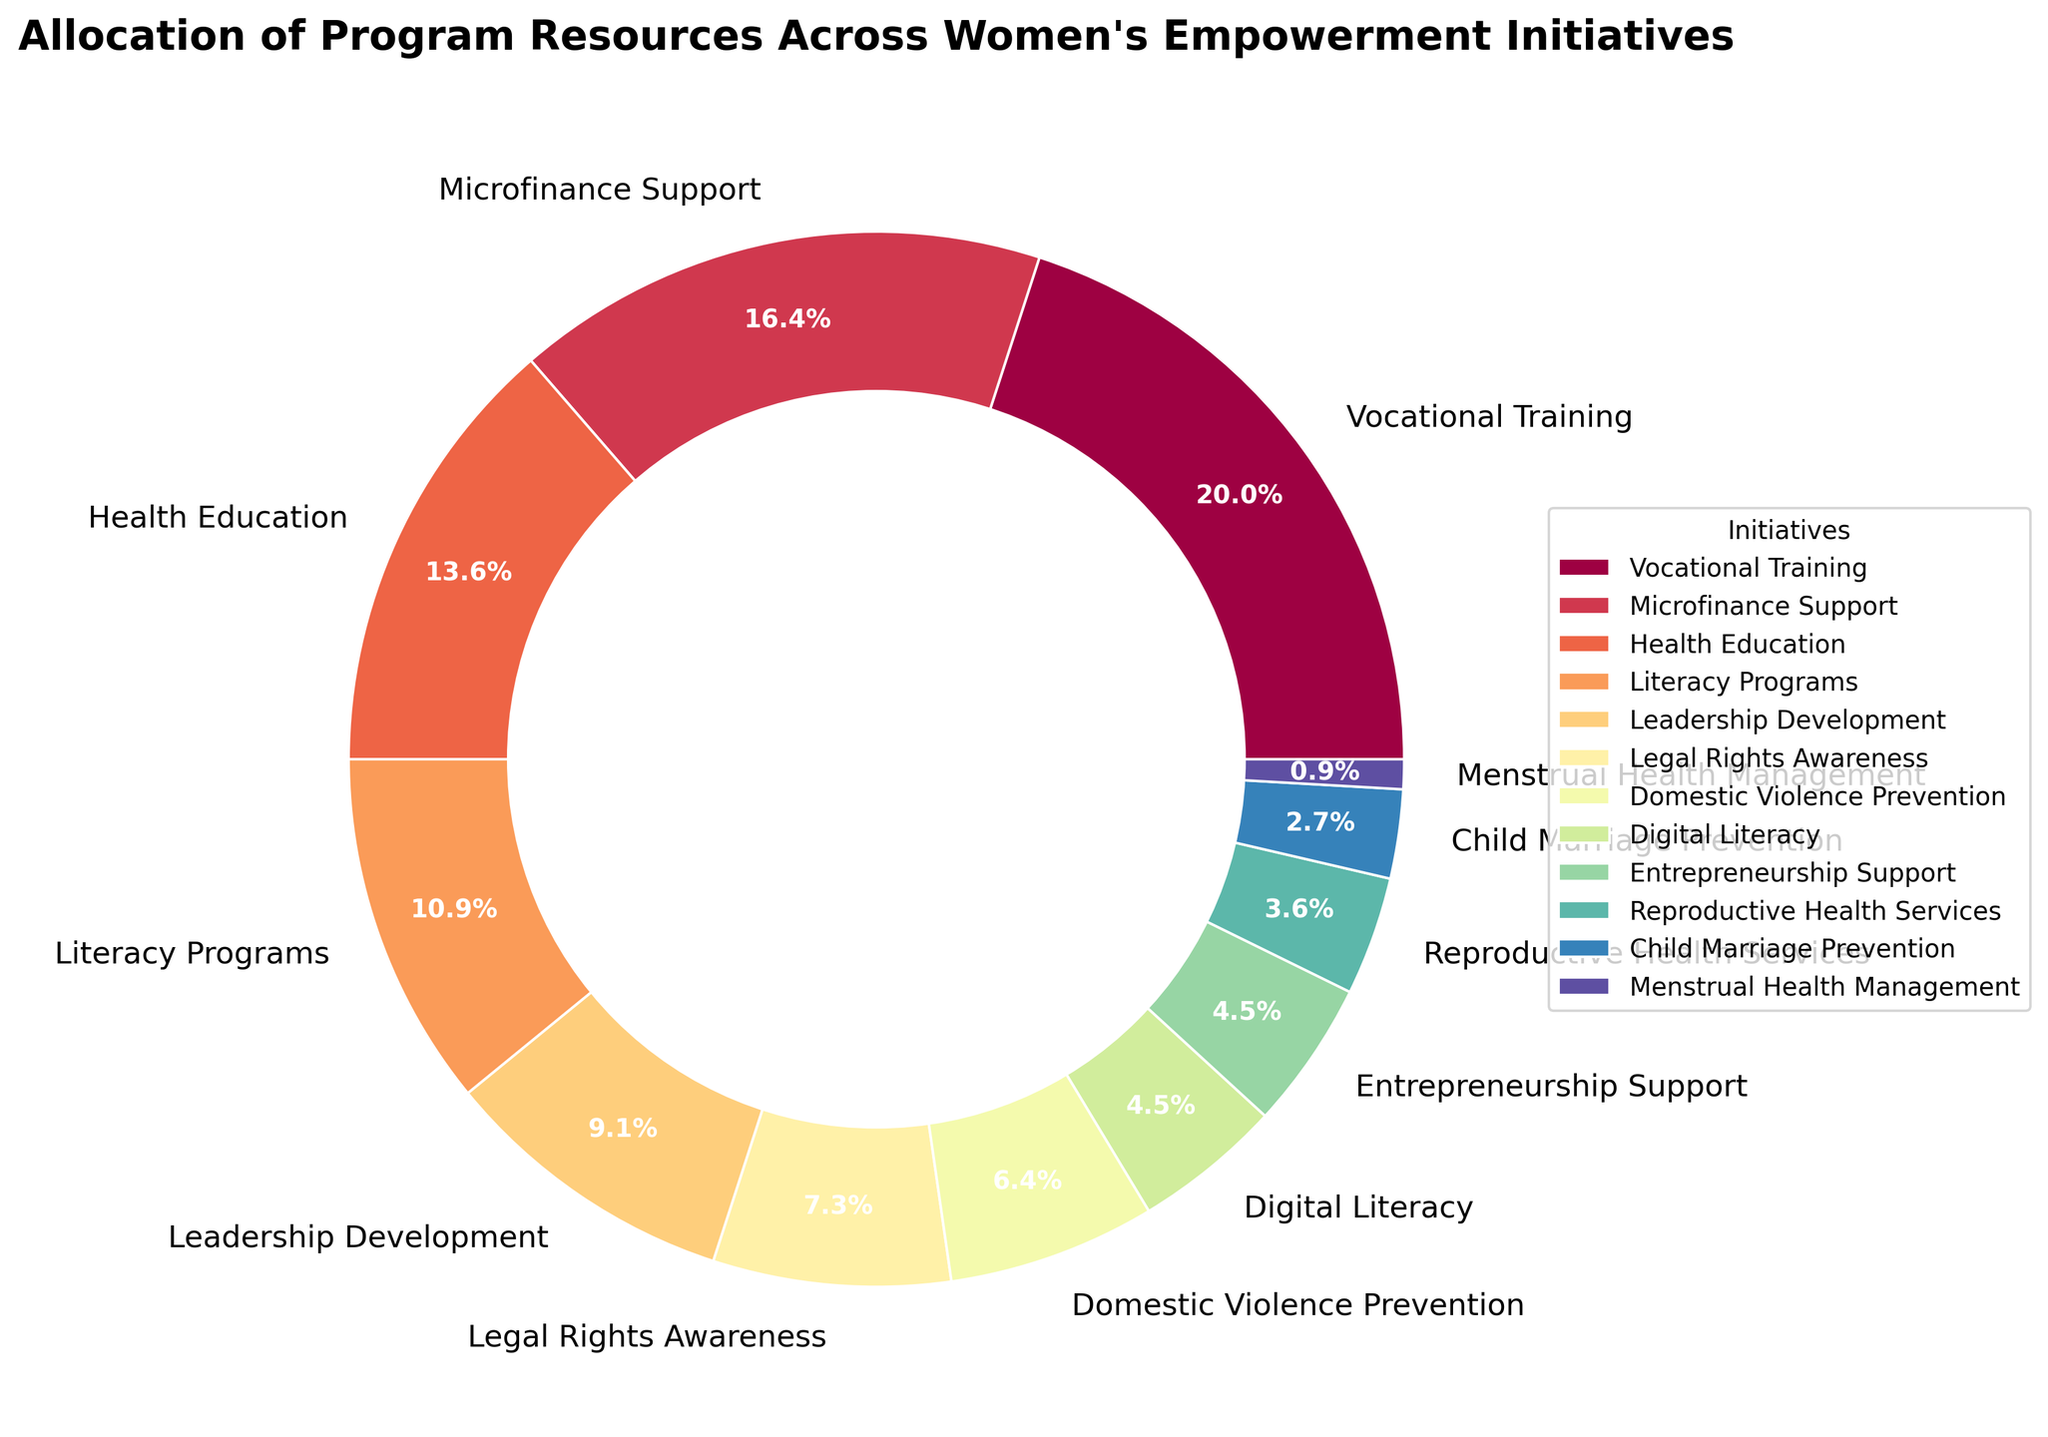Which initiative receives the most resources? The largest section of the pie chart represents the initiative with the highest percentage allocation. In this case, it is Vocational Training with 22%.
Answer: Vocational Training Which initiative receives the least resources? The smallest section of the pie chart represents the initiative with the lowest percentage allocation. In this case, it is Menstrual Health Management with 1%.
Answer: Menstrual Health Management How much more percentage is allocated to Vocational Training compared to Literacy Programs? To find the difference between the percentages allocated to these two initiatives, subtract the percentage of Literacy Programs from Vocational Training. That is 22% - 12% = 10%.
Answer: 10% Which initiatives have an equal percentage of resource allocation? To determine which initiatives have the same percentage, look for segments of the pie chart with equal size and check their labels. Digital Literacy and Entrepreneurship Support both have 5%.
Answer: Digital Literacy and Entrepreneurship Support What is the cumulative percentage of resources allocated to Health Education, Literacy Programs, and Leadership Development? Add the percentages of the identified initiatives: 15% (Health Education) + 12% (Literacy Programs) + 10% (Leadership Development) = 37%.
Answer: 37% Which initiative has a larger resource allocation: Legal Rights Awareness or Domestic Violence Prevention? Check the pie chart segments for both initiatives: Legal Rights Awareness (8%) is larger than Domestic Violence Prevention (7%).
Answer: Legal Rights Awareness What percentage of resources is allocated to initiatives focused on health (Health Education and Reproductive Health Services)? Add the percentages of Health Education and Reproductive Health Services: 15% + 4% = 19%.
Answer: 19% How much more percentage is allocated to Microfinance Support compared to Reproductive Health Services? To find the difference, subtract the percentage of Reproductive Health Services from Microfinance Support: 18% - 4% = 14%.
Answer: 14% Combine the resources allocated to Digital Literacy and Entrepreneurship Support. Do they together exceed the allocation to Health Education? Add the percentages of Digital Literacy and Entrepreneurship Support (5% + 5% = 10%) and compare it to Health Education (15%). 10% does not exceed 15%.
Answer: No Between Vocational Training and Leadership Development, which initiative's segment in the pie chart appears more prominently and why? Vocational Training appears more prominently because it has a larger percentage (22%) compared to Leadership Development (10%), resulting in a larger pie segment.
Answer: Vocational Training 